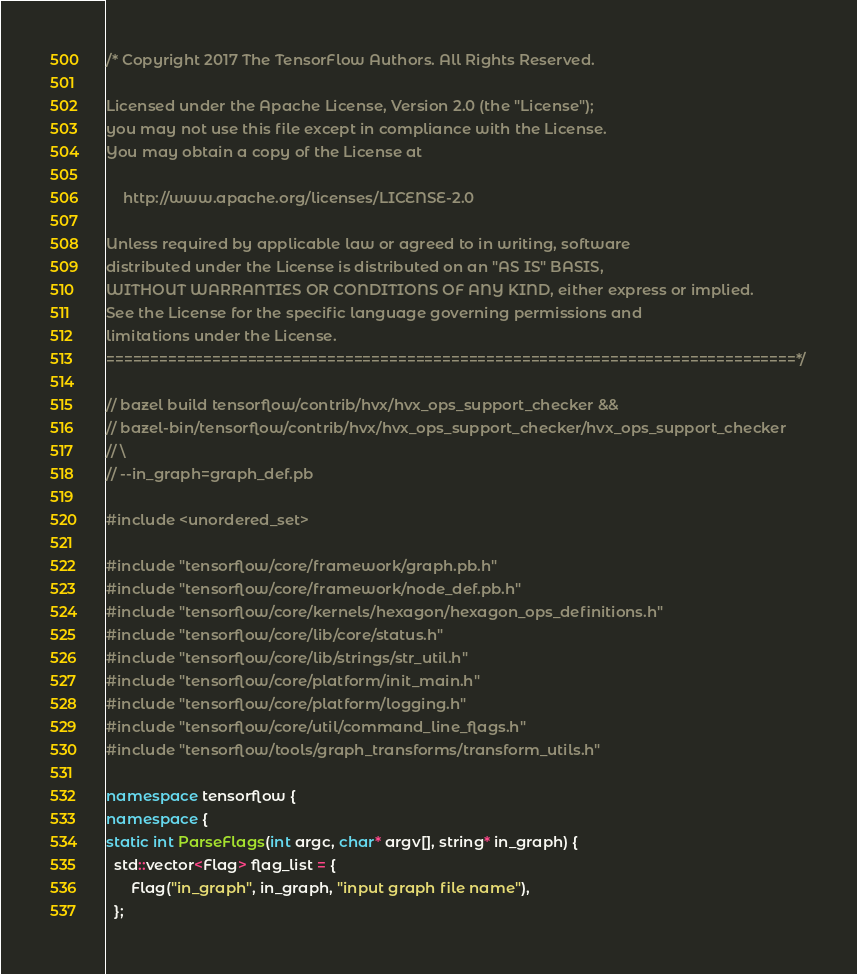Convert code to text. <code><loc_0><loc_0><loc_500><loc_500><_C++_>/* Copyright 2017 The TensorFlow Authors. All Rights Reserved.

Licensed under the Apache License, Version 2.0 (the "License");
you may not use this file except in compliance with the License.
You may obtain a copy of the License at

    http://www.apache.org/licenses/LICENSE-2.0

Unless required by applicable law or agreed to in writing, software
distributed under the License is distributed on an "AS IS" BASIS,
WITHOUT WARRANTIES OR CONDITIONS OF ANY KIND, either express or implied.
See the License for the specific language governing permissions and
limitations under the License.
==============================================================================*/

// bazel build tensorflow/contrib/hvx/hvx_ops_support_checker &&
// bazel-bin/tensorflow/contrib/hvx/hvx_ops_support_checker/hvx_ops_support_checker
// \
// --in_graph=graph_def.pb

#include <unordered_set>

#include "tensorflow/core/framework/graph.pb.h"
#include "tensorflow/core/framework/node_def.pb.h"
#include "tensorflow/core/kernels/hexagon/hexagon_ops_definitions.h"
#include "tensorflow/core/lib/core/status.h"
#include "tensorflow/core/lib/strings/str_util.h"
#include "tensorflow/core/platform/init_main.h"
#include "tensorflow/core/platform/logging.h"
#include "tensorflow/core/util/command_line_flags.h"
#include "tensorflow/tools/graph_transforms/transform_utils.h"

namespace tensorflow {
namespace {
static int ParseFlags(int argc, char* argv[], string* in_graph) {
  std::vector<Flag> flag_list = {
      Flag("in_graph", in_graph, "input graph file name"),
  };</code> 